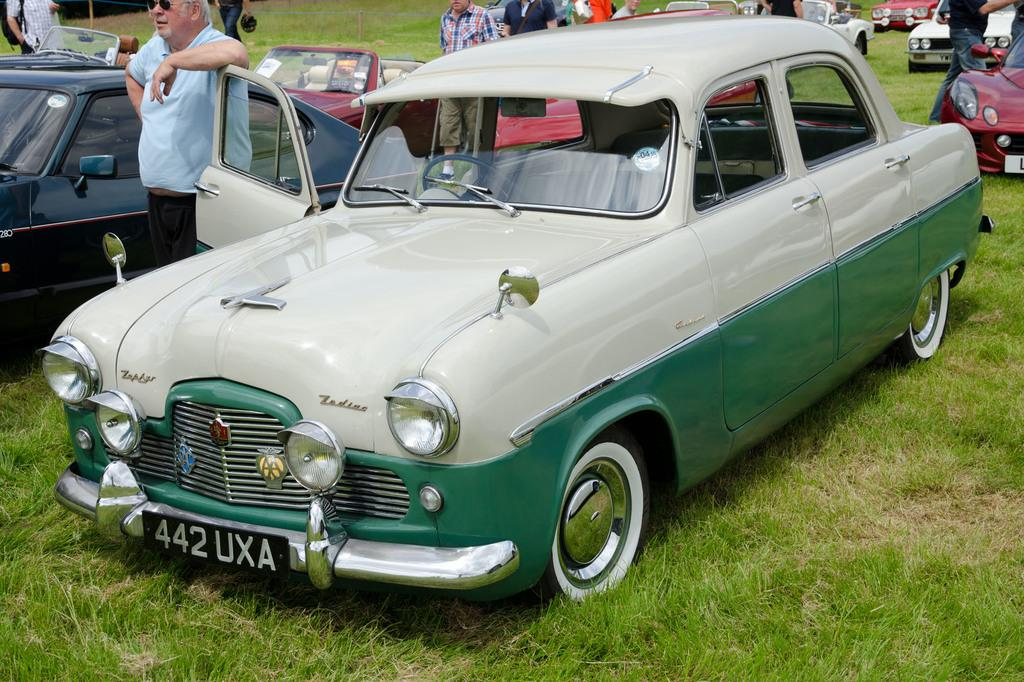What type of vehicles can be seen in the image? There are cars in the image. Can you describe the people visible in the image? There are people visible in the image. What type of vegetation is present in the image? There is grass in the image. What type of tomatoes can be seen growing in the image? There are no tomatoes present in the image; it only features cars, people, and grass. 